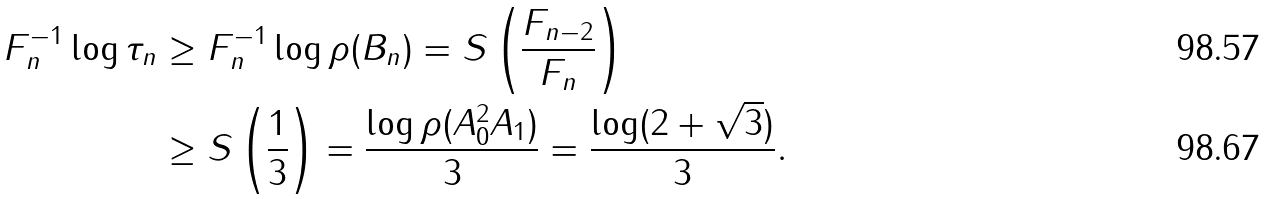<formula> <loc_0><loc_0><loc_500><loc_500>F _ { n } ^ { - 1 } \log \tau _ { n } & \geq F _ { n } ^ { - 1 } \log \rho ( B _ { n } ) = S \left ( \frac { F _ { n - 2 } } { F _ { n } } \right ) \\ & \geq S \left ( \frac { 1 } { 3 } \right ) = \frac { \log \rho ( A _ { 0 } ^ { 2 } A _ { 1 } ) } { 3 } = \frac { \log ( 2 + \sqrt { 3 } ) } { 3 } .</formula> 